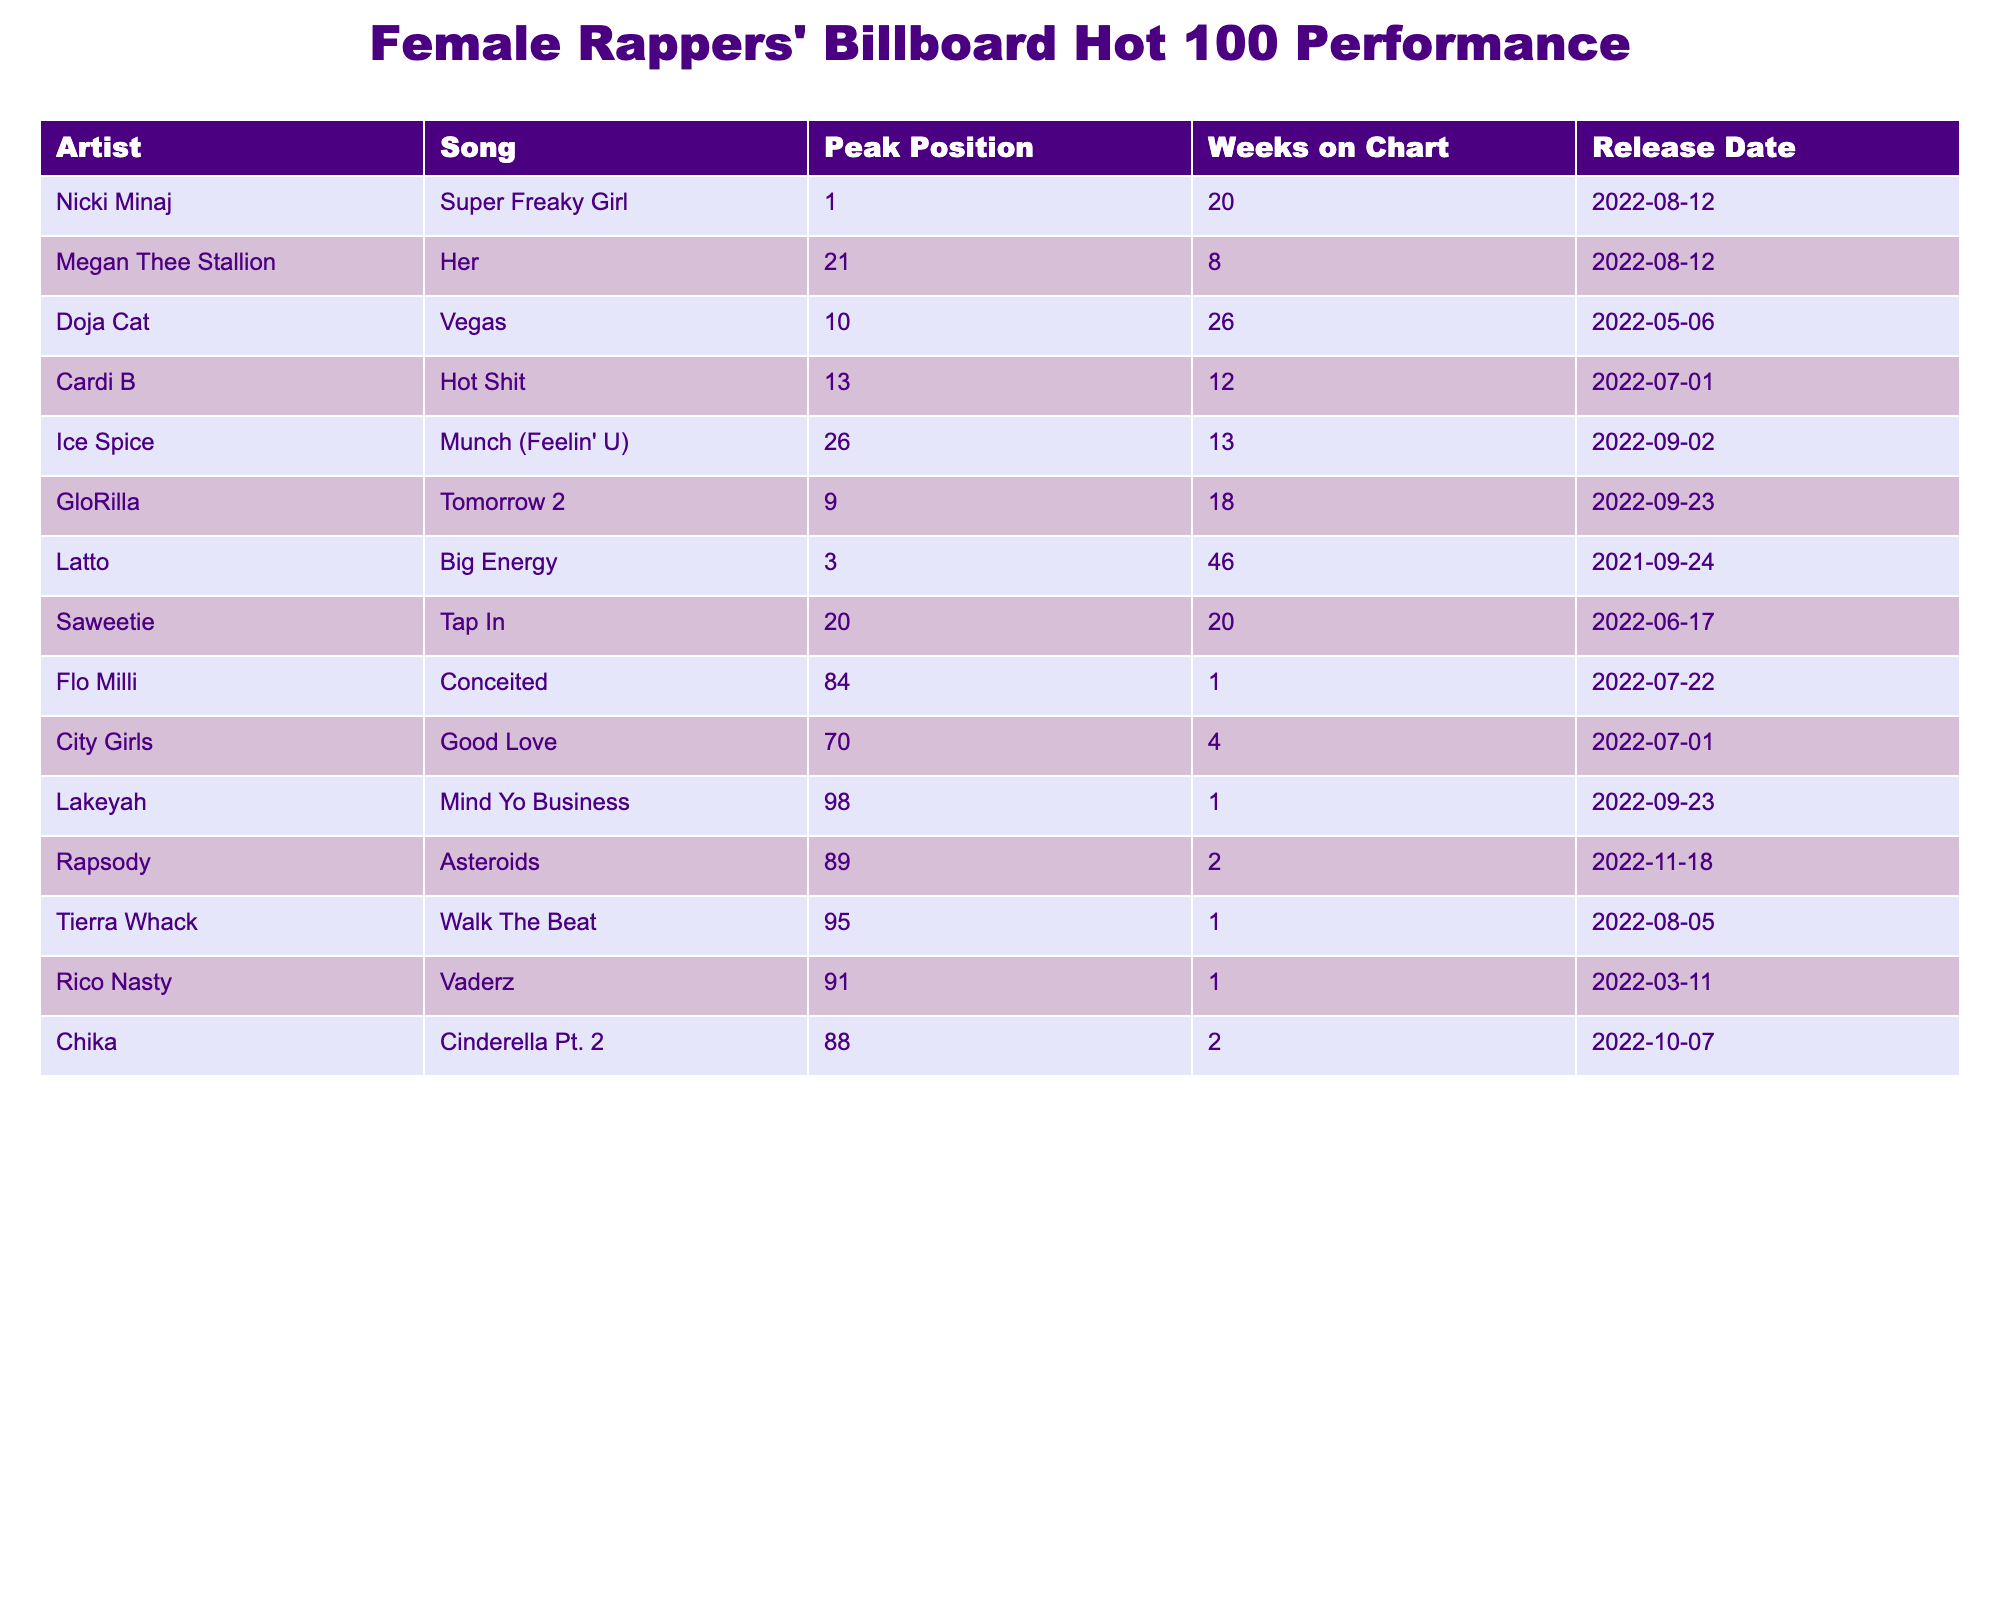What is the peak position of Nicki Minaj's song "Super Freaky Girl"? The table shows that the peak position for “Super Freaky Girl” by Nicki Minaj is 1.
Answer: 1 How many weeks did Doja Cat's song "Vegas" spend on the chart? According to the table, "Vegas" by Doja Cat spent 26 weeks on the chart.
Answer: 26 Which female rapper had the lowest peak position on the Billboard Hot 100? The table indicates that Lakeyah's song "Mind Yo Business" had the lowest peak position at 98.
Answer: 98 Do Megan Thee Stallion and Cardi B have songs that peaked in the top 20? Yes, Megan Thee Stallion's song "Her" peaked at 21 and Cardi B's "Hot Shit" peaked at 13, which is in the top 20.
Answer: Yes What is the average peak position of the songs listed in the table? To find the average peak position, we add the peak positions (1 + 21 + 10 + 13 + 26 + 9 + 3 + 20 + 84 + 70 + 98 + 89 + 95 + 91 + 88) = 1000. There are 15 songs, so the average is 1000 divided by 15, which equals approximately 66.67.
Answer: 66.67 Did any female rapper spend more than 40 weeks on the chart? Yes, Latto’s song "Big Energy" spent 46 weeks on the chart, which is more than 40 weeks.
Answer: Yes Which two songs had the same peak position of 20? The table shows that both "Her" by Megan Thee Stallion and "Tap In" by Saweetie peaked at position 20.
Answer: "Her" and "Tap In" How many songs peaked in the top 10? The table indicates that three songs peaked in the top 10: "Super Freaky Girl" (1), "Vegas" (10), and "Tomorrow 2" (9).
Answer: 3 What is the difference between the weeks on chart for the song "Conceited" and the song "Good Love"? "Conceited" by Flo Milli spent 1 week on the chart and "Good Love" by City Girls spent 4 weeks, hence the difference is 4 - 1 = 3 weeks.
Answer: 3 Which artist has the most weeks on the chart and how many weeks did they stay? The longest time on the chart is 46 weeks for Latto's song "Big Energy."
Answer: Latto, 46 weeks 